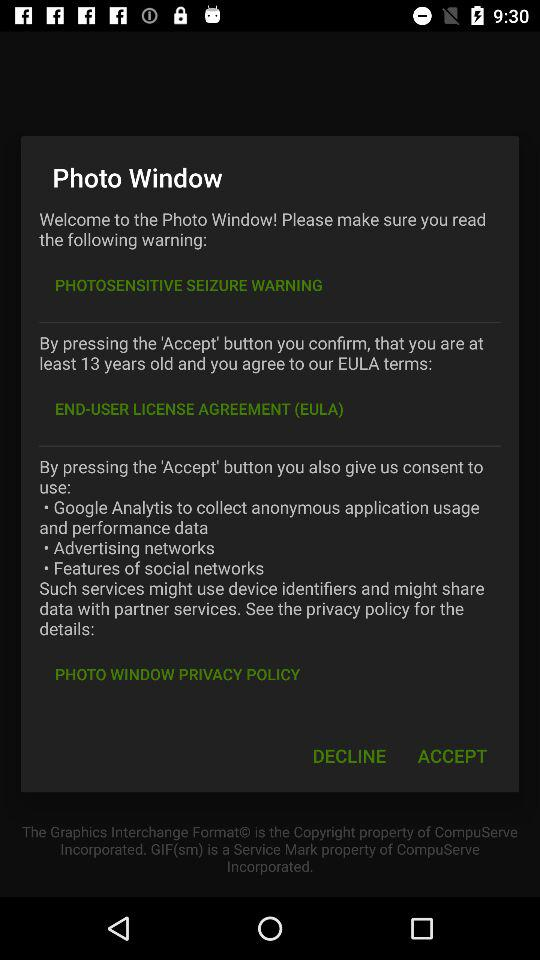What is the advantage of pressing 'Accept' button?
When the provided information is insufficient, respond with <no answer>. <no answer> 